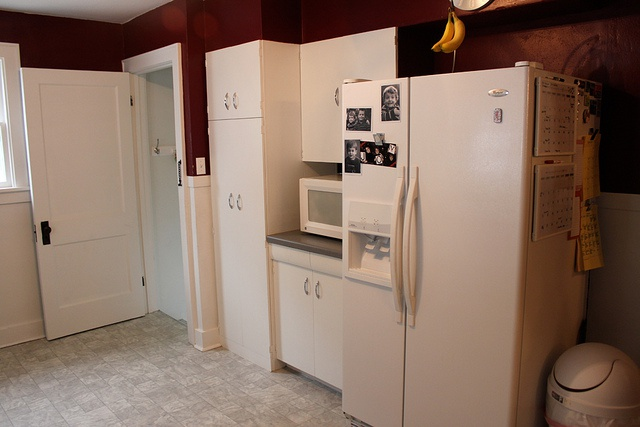Describe the objects in this image and their specific colors. I can see refrigerator in darkgray, tan, gray, and maroon tones, microwave in darkgray, gray, and tan tones, banana in darkgray, red, orange, black, and maroon tones, people in darkgray, gray, and black tones, and people in darkgray, black, and gray tones in this image. 